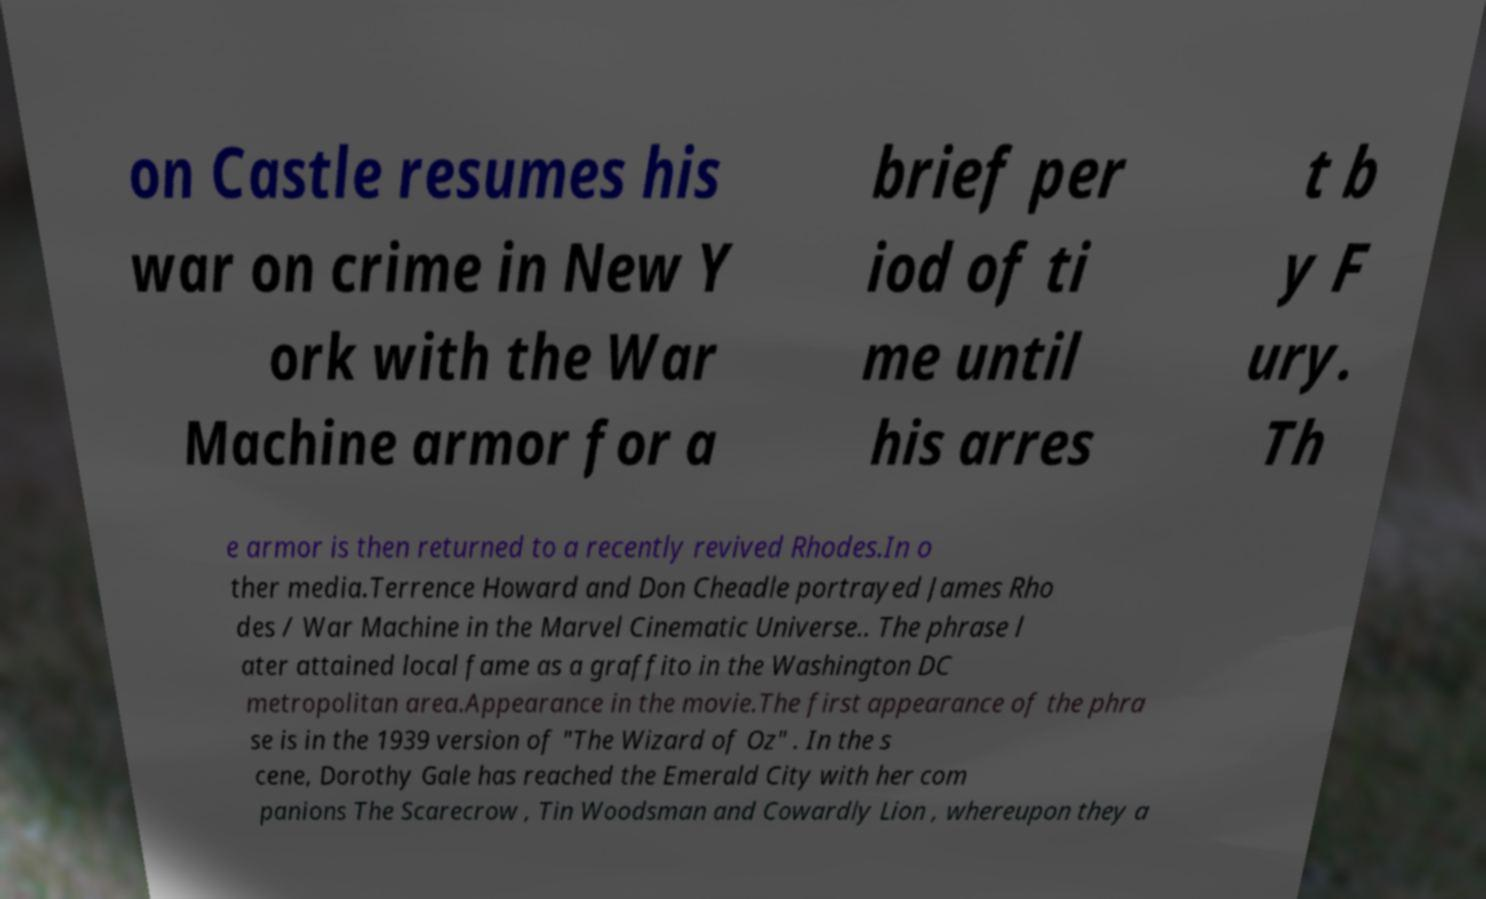What messages or text are displayed in this image? I need them in a readable, typed format. on Castle resumes his war on crime in New Y ork with the War Machine armor for a brief per iod of ti me until his arres t b y F ury. Th e armor is then returned to a recently revived Rhodes.In o ther media.Terrence Howard and Don Cheadle portrayed James Rho des / War Machine in the Marvel Cinematic Universe.. The phrase l ater attained local fame as a graffito in the Washington DC metropolitan area.Appearance in the movie.The first appearance of the phra se is in the 1939 version of "The Wizard of Oz" . In the s cene, Dorothy Gale has reached the Emerald City with her com panions The Scarecrow , Tin Woodsman and Cowardly Lion , whereupon they a 